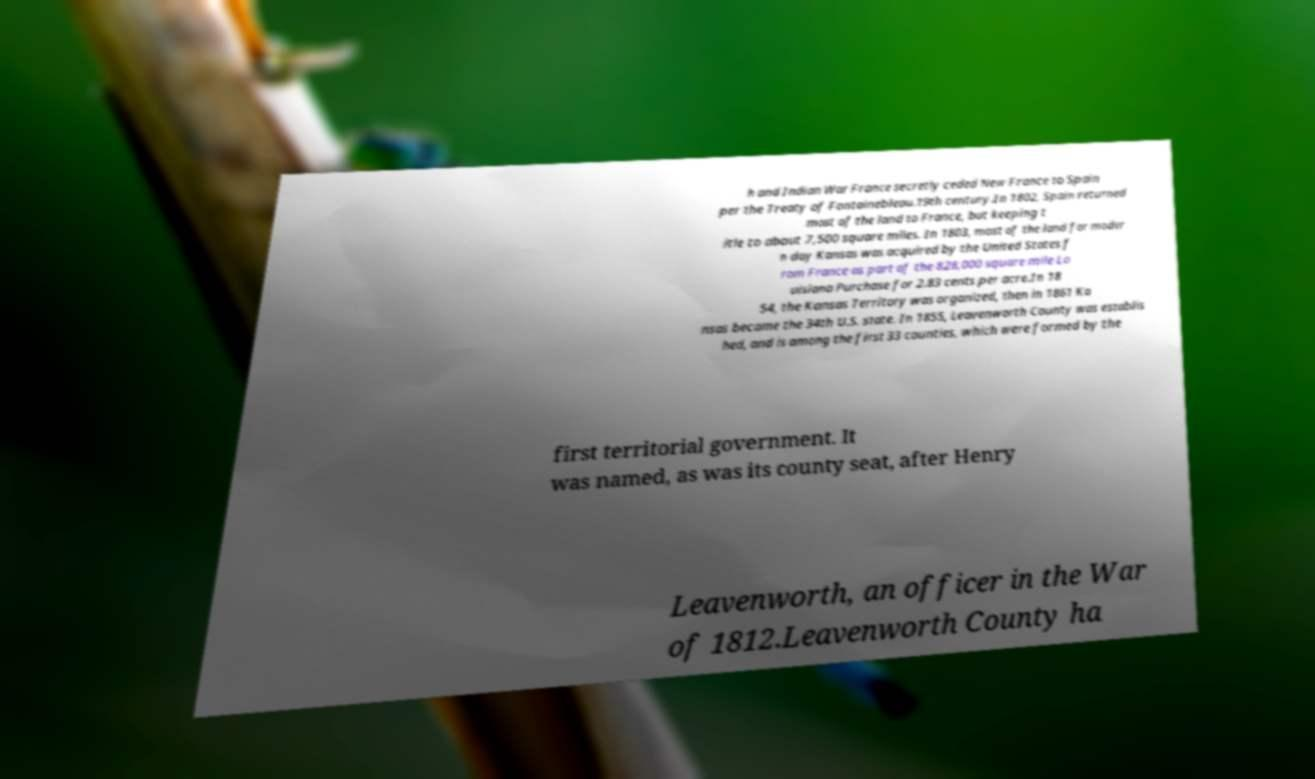Can you accurately transcribe the text from the provided image for me? h and Indian War France secretly ceded New France to Spain per the Treaty of Fontainebleau.19th century.In 1802, Spain returned most of the land to France, but keeping t itle to about 7,500 square miles. In 1803, most of the land for moder n day Kansas was acquired by the United States f rom France as part of the 828,000 square mile Lo uisiana Purchase for 2.83 cents per acre.In 18 54, the Kansas Territory was organized, then in 1861 Ka nsas became the 34th U.S. state. In 1855, Leavenworth County was establis hed, and is among the first 33 counties, which were formed by the first territorial government. It was named, as was its county seat, after Henry Leavenworth, an officer in the War of 1812.Leavenworth County ha 